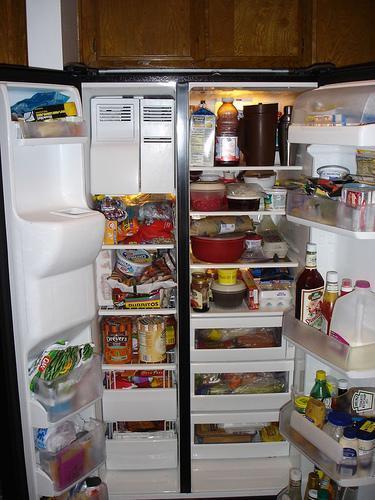How many containers of ice cream?
Give a very brief answer. 2. How many bottles are visible?
Give a very brief answer. 1. 